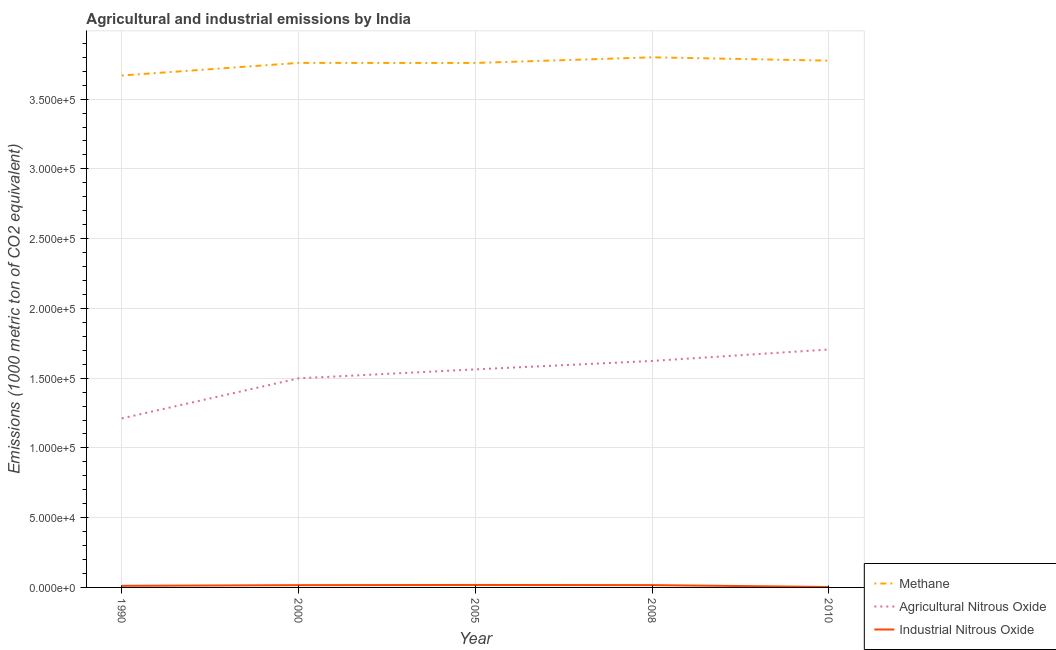Is the number of lines equal to the number of legend labels?
Provide a short and direct response. Yes. What is the amount of methane emissions in 2000?
Offer a very short reply. 3.76e+05. Across all years, what is the maximum amount of methane emissions?
Provide a short and direct response. 3.80e+05. Across all years, what is the minimum amount of agricultural nitrous oxide emissions?
Ensure brevity in your answer.  1.21e+05. In which year was the amount of agricultural nitrous oxide emissions minimum?
Your answer should be very brief. 1990. What is the total amount of agricultural nitrous oxide emissions in the graph?
Provide a short and direct response. 7.60e+05. What is the difference between the amount of agricultural nitrous oxide emissions in 1990 and that in 2008?
Give a very brief answer. -4.12e+04. What is the difference between the amount of industrial nitrous oxide emissions in 1990 and the amount of agricultural nitrous oxide emissions in 2000?
Your answer should be very brief. -1.49e+05. What is the average amount of industrial nitrous oxide emissions per year?
Provide a succinct answer. 1305.32. In the year 2010, what is the difference between the amount of industrial nitrous oxide emissions and amount of agricultural nitrous oxide emissions?
Give a very brief answer. -1.70e+05. What is the ratio of the amount of industrial nitrous oxide emissions in 2000 to that in 2008?
Your response must be concise. 0.99. What is the difference between the highest and the second highest amount of agricultural nitrous oxide emissions?
Offer a terse response. 8207.6. What is the difference between the highest and the lowest amount of agricultural nitrous oxide emissions?
Offer a very short reply. 4.94e+04. Is it the case that in every year, the sum of the amount of methane emissions and amount of agricultural nitrous oxide emissions is greater than the amount of industrial nitrous oxide emissions?
Make the answer very short. Yes. Is the amount of industrial nitrous oxide emissions strictly greater than the amount of methane emissions over the years?
Keep it short and to the point. No. How many years are there in the graph?
Give a very brief answer. 5. What is the difference between two consecutive major ticks on the Y-axis?
Make the answer very short. 5.00e+04. Are the values on the major ticks of Y-axis written in scientific E-notation?
Provide a short and direct response. Yes. Does the graph contain grids?
Keep it short and to the point. Yes. Where does the legend appear in the graph?
Offer a very short reply. Bottom right. How many legend labels are there?
Provide a short and direct response. 3. How are the legend labels stacked?
Make the answer very short. Vertical. What is the title of the graph?
Your answer should be compact. Agricultural and industrial emissions by India. Does "Coal" appear as one of the legend labels in the graph?
Offer a very short reply. No. What is the label or title of the Y-axis?
Provide a short and direct response. Emissions (1000 metric ton of CO2 equivalent). What is the Emissions (1000 metric ton of CO2 equivalent) in Methane in 1990?
Offer a terse response. 3.67e+05. What is the Emissions (1000 metric ton of CO2 equivalent) of Agricultural Nitrous Oxide in 1990?
Ensure brevity in your answer.  1.21e+05. What is the Emissions (1000 metric ton of CO2 equivalent) in Industrial Nitrous Oxide in 1990?
Give a very brief answer. 1146.7. What is the Emissions (1000 metric ton of CO2 equivalent) of Methane in 2000?
Provide a succinct answer. 3.76e+05. What is the Emissions (1000 metric ton of CO2 equivalent) of Agricultural Nitrous Oxide in 2000?
Your response must be concise. 1.50e+05. What is the Emissions (1000 metric ton of CO2 equivalent) of Industrial Nitrous Oxide in 2000?
Provide a short and direct response. 1643.3. What is the Emissions (1000 metric ton of CO2 equivalent) in Methane in 2005?
Ensure brevity in your answer.  3.76e+05. What is the Emissions (1000 metric ton of CO2 equivalent) of Agricultural Nitrous Oxide in 2005?
Offer a terse response. 1.56e+05. What is the Emissions (1000 metric ton of CO2 equivalent) of Industrial Nitrous Oxide in 2005?
Give a very brief answer. 1761.9. What is the Emissions (1000 metric ton of CO2 equivalent) of Methane in 2008?
Give a very brief answer. 3.80e+05. What is the Emissions (1000 metric ton of CO2 equivalent) of Agricultural Nitrous Oxide in 2008?
Provide a short and direct response. 1.62e+05. What is the Emissions (1000 metric ton of CO2 equivalent) of Industrial Nitrous Oxide in 2008?
Ensure brevity in your answer.  1659.8. What is the Emissions (1000 metric ton of CO2 equivalent) of Methane in 2010?
Your answer should be compact. 3.78e+05. What is the Emissions (1000 metric ton of CO2 equivalent) of Agricultural Nitrous Oxide in 2010?
Offer a very short reply. 1.71e+05. What is the Emissions (1000 metric ton of CO2 equivalent) of Industrial Nitrous Oxide in 2010?
Ensure brevity in your answer.  314.9. Across all years, what is the maximum Emissions (1000 metric ton of CO2 equivalent) in Methane?
Keep it short and to the point. 3.80e+05. Across all years, what is the maximum Emissions (1000 metric ton of CO2 equivalent) of Agricultural Nitrous Oxide?
Give a very brief answer. 1.71e+05. Across all years, what is the maximum Emissions (1000 metric ton of CO2 equivalent) of Industrial Nitrous Oxide?
Your answer should be compact. 1761.9. Across all years, what is the minimum Emissions (1000 metric ton of CO2 equivalent) in Methane?
Ensure brevity in your answer.  3.67e+05. Across all years, what is the minimum Emissions (1000 metric ton of CO2 equivalent) of Agricultural Nitrous Oxide?
Your response must be concise. 1.21e+05. Across all years, what is the minimum Emissions (1000 metric ton of CO2 equivalent) of Industrial Nitrous Oxide?
Your answer should be very brief. 314.9. What is the total Emissions (1000 metric ton of CO2 equivalent) of Methane in the graph?
Your answer should be very brief. 1.88e+06. What is the total Emissions (1000 metric ton of CO2 equivalent) of Agricultural Nitrous Oxide in the graph?
Offer a terse response. 7.60e+05. What is the total Emissions (1000 metric ton of CO2 equivalent) of Industrial Nitrous Oxide in the graph?
Your answer should be compact. 6526.6. What is the difference between the Emissions (1000 metric ton of CO2 equivalent) in Methane in 1990 and that in 2000?
Provide a short and direct response. -9029.4. What is the difference between the Emissions (1000 metric ton of CO2 equivalent) of Agricultural Nitrous Oxide in 1990 and that in 2000?
Provide a succinct answer. -2.87e+04. What is the difference between the Emissions (1000 metric ton of CO2 equivalent) in Industrial Nitrous Oxide in 1990 and that in 2000?
Offer a terse response. -496.6. What is the difference between the Emissions (1000 metric ton of CO2 equivalent) of Methane in 1990 and that in 2005?
Your answer should be compact. -8983.7. What is the difference between the Emissions (1000 metric ton of CO2 equivalent) in Agricultural Nitrous Oxide in 1990 and that in 2005?
Give a very brief answer. -3.51e+04. What is the difference between the Emissions (1000 metric ton of CO2 equivalent) in Industrial Nitrous Oxide in 1990 and that in 2005?
Make the answer very short. -615.2. What is the difference between the Emissions (1000 metric ton of CO2 equivalent) of Methane in 1990 and that in 2008?
Ensure brevity in your answer.  -1.30e+04. What is the difference between the Emissions (1000 metric ton of CO2 equivalent) in Agricultural Nitrous Oxide in 1990 and that in 2008?
Your answer should be compact. -4.12e+04. What is the difference between the Emissions (1000 metric ton of CO2 equivalent) in Industrial Nitrous Oxide in 1990 and that in 2008?
Your response must be concise. -513.1. What is the difference between the Emissions (1000 metric ton of CO2 equivalent) of Methane in 1990 and that in 2010?
Your answer should be very brief. -1.06e+04. What is the difference between the Emissions (1000 metric ton of CO2 equivalent) in Agricultural Nitrous Oxide in 1990 and that in 2010?
Provide a short and direct response. -4.94e+04. What is the difference between the Emissions (1000 metric ton of CO2 equivalent) in Industrial Nitrous Oxide in 1990 and that in 2010?
Provide a short and direct response. 831.8. What is the difference between the Emissions (1000 metric ton of CO2 equivalent) in Methane in 2000 and that in 2005?
Your answer should be very brief. 45.7. What is the difference between the Emissions (1000 metric ton of CO2 equivalent) in Agricultural Nitrous Oxide in 2000 and that in 2005?
Your answer should be compact. -6428.4. What is the difference between the Emissions (1000 metric ton of CO2 equivalent) of Industrial Nitrous Oxide in 2000 and that in 2005?
Provide a succinct answer. -118.6. What is the difference between the Emissions (1000 metric ton of CO2 equivalent) of Methane in 2000 and that in 2008?
Your answer should be compact. -4005.8. What is the difference between the Emissions (1000 metric ton of CO2 equivalent) of Agricultural Nitrous Oxide in 2000 and that in 2008?
Provide a succinct answer. -1.25e+04. What is the difference between the Emissions (1000 metric ton of CO2 equivalent) in Industrial Nitrous Oxide in 2000 and that in 2008?
Your answer should be very brief. -16.5. What is the difference between the Emissions (1000 metric ton of CO2 equivalent) of Methane in 2000 and that in 2010?
Offer a very short reply. -1614.3. What is the difference between the Emissions (1000 metric ton of CO2 equivalent) in Agricultural Nitrous Oxide in 2000 and that in 2010?
Your answer should be compact. -2.07e+04. What is the difference between the Emissions (1000 metric ton of CO2 equivalent) in Industrial Nitrous Oxide in 2000 and that in 2010?
Your response must be concise. 1328.4. What is the difference between the Emissions (1000 metric ton of CO2 equivalent) of Methane in 2005 and that in 2008?
Your answer should be compact. -4051.5. What is the difference between the Emissions (1000 metric ton of CO2 equivalent) in Agricultural Nitrous Oxide in 2005 and that in 2008?
Your answer should be compact. -6044.2. What is the difference between the Emissions (1000 metric ton of CO2 equivalent) in Industrial Nitrous Oxide in 2005 and that in 2008?
Your response must be concise. 102.1. What is the difference between the Emissions (1000 metric ton of CO2 equivalent) of Methane in 2005 and that in 2010?
Offer a very short reply. -1660. What is the difference between the Emissions (1000 metric ton of CO2 equivalent) in Agricultural Nitrous Oxide in 2005 and that in 2010?
Keep it short and to the point. -1.43e+04. What is the difference between the Emissions (1000 metric ton of CO2 equivalent) of Industrial Nitrous Oxide in 2005 and that in 2010?
Your response must be concise. 1447. What is the difference between the Emissions (1000 metric ton of CO2 equivalent) of Methane in 2008 and that in 2010?
Your answer should be compact. 2391.5. What is the difference between the Emissions (1000 metric ton of CO2 equivalent) of Agricultural Nitrous Oxide in 2008 and that in 2010?
Ensure brevity in your answer.  -8207.6. What is the difference between the Emissions (1000 metric ton of CO2 equivalent) of Industrial Nitrous Oxide in 2008 and that in 2010?
Make the answer very short. 1344.9. What is the difference between the Emissions (1000 metric ton of CO2 equivalent) in Methane in 1990 and the Emissions (1000 metric ton of CO2 equivalent) in Agricultural Nitrous Oxide in 2000?
Make the answer very short. 2.17e+05. What is the difference between the Emissions (1000 metric ton of CO2 equivalent) of Methane in 1990 and the Emissions (1000 metric ton of CO2 equivalent) of Industrial Nitrous Oxide in 2000?
Keep it short and to the point. 3.65e+05. What is the difference between the Emissions (1000 metric ton of CO2 equivalent) of Agricultural Nitrous Oxide in 1990 and the Emissions (1000 metric ton of CO2 equivalent) of Industrial Nitrous Oxide in 2000?
Your response must be concise. 1.20e+05. What is the difference between the Emissions (1000 metric ton of CO2 equivalent) of Methane in 1990 and the Emissions (1000 metric ton of CO2 equivalent) of Agricultural Nitrous Oxide in 2005?
Your answer should be compact. 2.11e+05. What is the difference between the Emissions (1000 metric ton of CO2 equivalent) in Methane in 1990 and the Emissions (1000 metric ton of CO2 equivalent) in Industrial Nitrous Oxide in 2005?
Keep it short and to the point. 3.65e+05. What is the difference between the Emissions (1000 metric ton of CO2 equivalent) of Agricultural Nitrous Oxide in 1990 and the Emissions (1000 metric ton of CO2 equivalent) of Industrial Nitrous Oxide in 2005?
Make the answer very short. 1.19e+05. What is the difference between the Emissions (1000 metric ton of CO2 equivalent) in Methane in 1990 and the Emissions (1000 metric ton of CO2 equivalent) in Agricultural Nitrous Oxide in 2008?
Offer a terse response. 2.05e+05. What is the difference between the Emissions (1000 metric ton of CO2 equivalent) in Methane in 1990 and the Emissions (1000 metric ton of CO2 equivalent) in Industrial Nitrous Oxide in 2008?
Keep it short and to the point. 3.65e+05. What is the difference between the Emissions (1000 metric ton of CO2 equivalent) of Agricultural Nitrous Oxide in 1990 and the Emissions (1000 metric ton of CO2 equivalent) of Industrial Nitrous Oxide in 2008?
Make the answer very short. 1.19e+05. What is the difference between the Emissions (1000 metric ton of CO2 equivalent) of Methane in 1990 and the Emissions (1000 metric ton of CO2 equivalent) of Agricultural Nitrous Oxide in 2010?
Your response must be concise. 1.96e+05. What is the difference between the Emissions (1000 metric ton of CO2 equivalent) in Methane in 1990 and the Emissions (1000 metric ton of CO2 equivalent) in Industrial Nitrous Oxide in 2010?
Offer a terse response. 3.67e+05. What is the difference between the Emissions (1000 metric ton of CO2 equivalent) of Agricultural Nitrous Oxide in 1990 and the Emissions (1000 metric ton of CO2 equivalent) of Industrial Nitrous Oxide in 2010?
Make the answer very short. 1.21e+05. What is the difference between the Emissions (1000 metric ton of CO2 equivalent) of Methane in 2000 and the Emissions (1000 metric ton of CO2 equivalent) of Agricultural Nitrous Oxide in 2005?
Offer a terse response. 2.20e+05. What is the difference between the Emissions (1000 metric ton of CO2 equivalent) of Methane in 2000 and the Emissions (1000 metric ton of CO2 equivalent) of Industrial Nitrous Oxide in 2005?
Your response must be concise. 3.74e+05. What is the difference between the Emissions (1000 metric ton of CO2 equivalent) in Agricultural Nitrous Oxide in 2000 and the Emissions (1000 metric ton of CO2 equivalent) in Industrial Nitrous Oxide in 2005?
Make the answer very short. 1.48e+05. What is the difference between the Emissions (1000 metric ton of CO2 equivalent) of Methane in 2000 and the Emissions (1000 metric ton of CO2 equivalent) of Agricultural Nitrous Oxide in 2008?
Your response must be concise. 2.14e+05. What is the difference between the Emissions (1000 metric ton of CO2 equivalent) in Methane in 2000 and the Emissions (1000 metric ton of CO2 equivalent) in Industrial Nitrous Oxide in 2008?
Ensure brevity in your answer.  3.74e+05. What is the difference between the Emissions (1000 metric ton of CO2 equivalent) of Agricultural Nitrous Oxide in 2000 and the Emissions (1000 metric ton of CO2 equivalent) of Industrial Nitrous Oxide in 2008?
Make the answer very short. 1.48e+05. What is the difference between the Emissions (1000 metric ton of CO2 equivalent) in Methane in 2000 and the Emissions (1000 metric ton of CO2 equivalent) in Agricultural Nitrous Oxide in 2010?
Give a very brief answer. 2.05e+05. What is the difference between the Emissions (1000 metric ton of CO2 equivalent) in Methane in 2000 and the Emissions (1000 metric ton of CO2 equivalent) in Industrial Nitrous Oxide in 2010?
Your answer should be compact. 3.76e+05. What is the difference between the Emissions (1000 metric ton of CO2 equivalent) in Agricultural Nitrous Oxide in 2000 and the Emissions (1000 metric ton of CO2 equivalent) in Industrial Nitrous Oxide in 2010?
Give a very brief answer. 1.50e+05. What is the difference between the Emissions (1000 metric ton of CO2 equivalent) of Methane in 2005 and the Emissions (1000 metric ton of CO2 equivalent) of Agricultural Nitrous Oxide in 2008?
Your response must be concise. 2.14e+05. What is the difference between the Emissions (1000 metric ton of CO2 equivalent) in Methane in 2005 and the Emissions (1000 metric ton of CO2 equivalent) in Industrial Nitrous Oxide in 2008?
Provide a succinct answer. 3.74e+05. What is the difference between the Emissions (1000 metric ton of CO2 equivalent) in Agricultural Nitrous Oxide in 2005 and the Emissions (1000 metric ton of CO2 equivalent) in Industrial Nitrous Oxide in 2008?
Keep it short and to the point. 1.55e+05. What is the difference between the Emissions (1000 metric ton of CO2 equivalent) in Methane in 2005 and the Emissions (1000 metric ton of CO2 equivalent) in Agricultural Nitrous Oxide in 2010?
Provide a succinct answer. 2.05e+05. What is the difference between the Emissions (1000 metric ton of CO2 equivalent) in Methane in 2005 and the Emissions (1000 metric ton of CO2 equivalent) in Industrial Nitrous Oxide in 2010?
Keep it short and to the point. 3.76e+05. What is the difference between the Emissions (1000 metric ton of CO2 equivalent) in Agricultural Nitrous Oxide in 2005 and the Emissions (1000 metric ton of CO2 equivalent) in Industrial Nitrous Oxide in 2010?
Give a very brief answer. 1.56e+05. What is the difference between the Emissions (1000 metric ton of CO2 equivalent) in Methane in 2008 and the Emissions (1000 metric ton of CO2 equivalent) in Agricultural Nitrous Oxide in 2010?
Your response must be concise. 2.09e+05. What is the difference between the Emissions (1000 metric ton of CO2 equivalent) in Methane in 2008 and the Emissions (1000 metric ton of CO2 equivalent) in Industrial Nitrous Oxide in 2010?
Ensure brevity in your answer.  3.80e+05. What is the difference between the Emissions (1000 metric ton of CO2 equivalent) of Agricultural Nitrous Oxide in 2008 and the Emissions (1000 metric ton of CO2 equivalent) of Industrial Nitrous Oxide in 2010?
Make the answer very short. 1.62e+05. What is the average Emissions (1000 metric ton of CO2 equivalent) of Methane per year?
Ensure brevity in your answer.  3.75e+05. What is the average Emissions (1000 metric ton of CO2 equivalent) in Agricultural Nitrous Oxide per year?
Your response must be concise. 1.52e+05. What is the average Emissions (1000 metric ton of CO2 equivalent) of Industrial Nitrous Oxide per year?
Your answer should be very brief. 1305.32. In the year 1990, what is the difference between the Emissions (1000 metric ton of CO2 equivalent) of Methane and Emissions (1000 metric ton of CO2 equivalent) of Agricultural Nitrous Oxide?
Your response must be concise. 2.46e+05. In the year 1990, what is the difference between the Emissions (1000 metric ton of CO2 equivalent) of Methane and Emissions (1000 metric ton of CO2 equivalent) of Industrial Nitrous Oxide?
Provide a succinct answer. 3.66e+05. In the year 1990, what is the difference between the Emissions (1000 metric ton of CO2 equivalent) in Agricultural Nitrous Oxide and Emissions (1000 metric ton of CO2 equivalent) in Industrial Nitrous Oxide?
Your response must be concise. 1.20e+05. In the year 2000, what is the difference between the Emissions (1000 metric ton of CO2 equivalent) of Methane and Emissions (1000 metric ton of CO2 equivalent) of Agricultural Nitrous Oxide?
Keep it short and to the point. 2.26e+05. In the year 2000, what is the difference between the Emissions (1000 metric ton of CO2 equivalent) in Methane and Emissions (1000 metric ton of CO2 equivalent) in Industrial Nitrous Oxide?
Give a very brief answer. 3.74e+05. In the year 2000, what is the difference between the Emissions (1000 metric ton of CO2 equivalent) of Agricultural Nitrous Oxide and Emissions (1000 metric ton of CO2 equivalent) of Industrial Nitrous Oxide?
Offer a terse response. 1.48e+05. In the year 2005, what is the difference between the Emissions (1000 metric ton of CO2 equivalent) in Methane and Emissions (1000 metric ton of CO2 equivalent) in Agricultural Nitrous Oxide?
Offer a terse response. 2.20e+05. In the year 2005, what is the difference between the Emissions (1000 metric ton of CO2 equivalent) in Methane and Emissions (1000 metric ton of CO2 equivalent) in Industrial Nitrous Oxide?
Provide a short and direct response. 3.74e+05. In the year 2005, what is the difference between the Emissions (1000 metric ton of CO2 equivalent) in Agricultural Nitrous Oxide and Emissions (1000 metric ton of CO2 equivalent) in Industrial Nitrous Oxide?
Make the answer very short. 1.55e+05. In the year 2008, what is the difference between the Emissions (1000 metric ton of CO2 equivalent) in Methane and Emissions (1000 metric ton of CO2 equivalent) in Agricultural Nitrous Oxide?
Keep it short and to the point. 2.18e+05. In the year 2008, what is the difference between the Emissions (1000 metric ton of CO2 equivalent) in Methane and Emissions (1000 metric ton of CO2 equivalent) in Industrial Nitrous Oxide?
Provide a short and direct response. 3.78e+05. In the year 2008, what is the difference between the Emissions (1000 metric ton of CO2 equivalent) in Agricultural Nitrous Oxide and Emissions (1000 metric ton of CO2 equivalent) in Industrial Nitrous Oxide?
Ensure brevity in your answer.  1.61e+05. In the year 2010, what is the difference between the Emissions (1000 metric ton of CO2 equivalent) in Methane and Emissions (1000 metric ton of CO2 equivalent) in Agricultural Nitrous Oxide?
Offer a very short reply. 2.07e+05. In the year 2010, what is the difference between the Emissions (1000 metric ton of CO2 equivalent) in Methane and Emissions (1000 metric ton of CO2 equivalent) in Industrial Nitrous Oxide?
Your response must be concise. 3.77e+05. In the year 2010, what is the difference between the Emissions (1000 metric ton of CO2 equivalent) of Agricultural Nitrous Oxide and Emissions (1000 metric ton of CO2 equivalent) of Industrial Nitrous Oxide?
Make the answer very short. 1.70e+05. What is the ratio of the Emissions (1000 metric ton of CO2 equivalent) in Methane in 1990 to that in 2000?
Provide a succinct answer. 0.98. What is the ratio of the Emissions (1000 metric ton of CO2 equivalent) of Agricultural Nitrous Oxide in 1990 to that in 2000?
Provide a succinct answer. 0.81. What is the ratio of the Emissions (1000 metric ton of CO2 equivalent) in Industrial Nitrous Oxide in 1990 to that in 2000?
Your response must be concise. 0.7. What is the ratio of the Emissions (1000 metric ton of CO2 equivalent) of Methane in 1990 to that in 2005?
Make the answer very short. 0.98. What is the ratio of the Emissions (1000 metric ton of CO2 equivalent) in Agricultural Nitrous Oxide in 1990 to that in 2005?
Offer a terse response. 0.78. What is the ratio of the Emissions (1000 metric ton of CO2 equivalent) of Industrial Nitrous Oxide in 1990 to that in 2005?
Provide a short and direct response. 0.65. What is the ratio of the Emissions (1000 metric ton of CO2 equivalent) in Methane in 1990 to that in 2008?
Your answer should be very brief. 0.97. What is the ratio of the Emissions (1000 metric ton of CO2 equivalent) of Agricultural Nitrous Oxide in 1990 to that in 2008?
Give a very brief answer. 0.75. What is the ratio of the Emissions (1000 metric ton of CO2 equivalent) of Industrial Nitrous Oxide in 1990 to that in 2008?
Give a very brief answer. 0.69. What is the ratio of the Emissions (1000 metric ton of CO2 equivalent) of Methane in 1990 to that in 2010?
Give a very brief answer. 0.97. What is the ratio of the Emissions (1000 metric ton of CO2 equivalent) in Agricultural Nitrous Oxide in 1990 to that in 2010?
Provide a short and direct response. 0.71. What is the ratio of the Emissions (1000 metric ton of CO2 equivalent) in Industrial Nitrous Oxide in 1990 to that in 2010?
Offer a very short reply. 3.64. What is the ratio of the Emissions (1000 metric ton of CO2 equivalent) of Agricultural Nitrous Oxide in 2000 to that in 2005?
Make the answer very short. 0.96. What is the ratio of the Emissions (1000 metric ton of CO2 equivalent) of Industrial Nitrous Oxide in 2000 to that in 2005?
Offer a very short reply. 0.93. What is the ratio of the Emissions (1000 metric ton of CO2 equivalent) of Methane in 2000 to that in 2008?
Make the answer very short. 0.99. What is the ratio of the Emissions (1000 metric ton of CO2 equivalent) in Agricultural Nitrous Oxide in 2000 to that in 2008?
Give a very brief answer. 0.92. What is the ratio of the Emissions (1000 metric ton of CO2 equivalent) of Industrial Nitrous Oxide in 2000 to that in 2008?
Provide a short and direct response. 0.99. What is the ratio of the Emissions (1000 metric ton of CO2 equivalent) of Methane in 2000 to that in 2010?
Your response must be concise. 1. What is the ratio of the Emissions (1000 metric ton of CO2 equivalent) of Agricultural Nitrous Oxide in 2000 to that in 2010?
Provide a short and direct response. 0.88. What is the ratio of the Emissions (1000 metric ton of CO2 equivalent) in Industrial Nitrous Oxide in 2000 to that in 2010?
Keep it short and to the point. 5.22. What is the ratio of the Emissions (1000 metric ton of CO2 equivalent) in Methane in 2005 to that in 2008?
Your response must be concise. 0.99. What is the ratio of the Emissions (1000 metric ton of CO2 equivalent) of Agricultural Nitrous Oxide in 2005 to that in 2008?
Offer a very short reply. 0.96. What is the ratio of the Emissions (1000 metric ton of CO2 equivalent) in Industrial Nitrous Oxide in 2005 to that in 2008?
Your answer should be compact. 1.06. What is the ratio of the Emissions (1000 metric ton of CO2 equivalent) in Agricultural Nitrous Oxide in 2005 to that in 2010?
Your answer should be compact. 0.92. What is the ratio of the Emissions (1000 metric ton of CO2 equivalent) of Industrial Nitrous Oxide in 2005 to that in 2010?
Offer a terse response. 5.6. What is the ratio of the Emissions (1000 metric ton of CO2 equivalent) of Methane in 2008 to that in 2010?
Offer a very short reply. 1.01. What is the ratio of the Emissions (1000 metric ton of CO2 equivalent) of Agricultural Nitrous Oxide in 2008 to that in 2010?
Keep it short and to the point. 0.95. What is the ratio of the Emissions (1000 metric ton of CO2 equivalent) in Industrial Nitrous Oxide in 2008 to that in 2010?
Provide a succinct answer. 5.27. What is the difference between the highest and the second highest Emissions (1000 metric ton of CO2 equivalent) in Methane?
Your response must be concise. 2391.5. What is the difference between the highest and the second highest Emissions (1000 metric ton of CO2 equivalent) of Agricultural Nitrous Oxide?
Provide a succinct answer. 8207.6. What is the difference between the highest and the second highest Emissions (1000 metric ton of CO2 equivalent) in Industrial Nitrous Oxide?
Your response must be concise. 102.1. What is the difference between the highest and the lowest Emissions (1000 metric ton of CO2 equivalent) of Methane?
Make the answer very short. 1.30e+04. What is the difference between the highest and the lowest Emissions (1000 metric ton of CO2 equivalent) of Agricultural Nitrous Oxide?
Ensure brevity in your answer.  4.94e+04. What is the difference between the highest and the lowest Emissions (1000 metric ton of CO2 equivalent) of Industrial Nitrous Oxide?
Provide a short and direct response. 1447. 